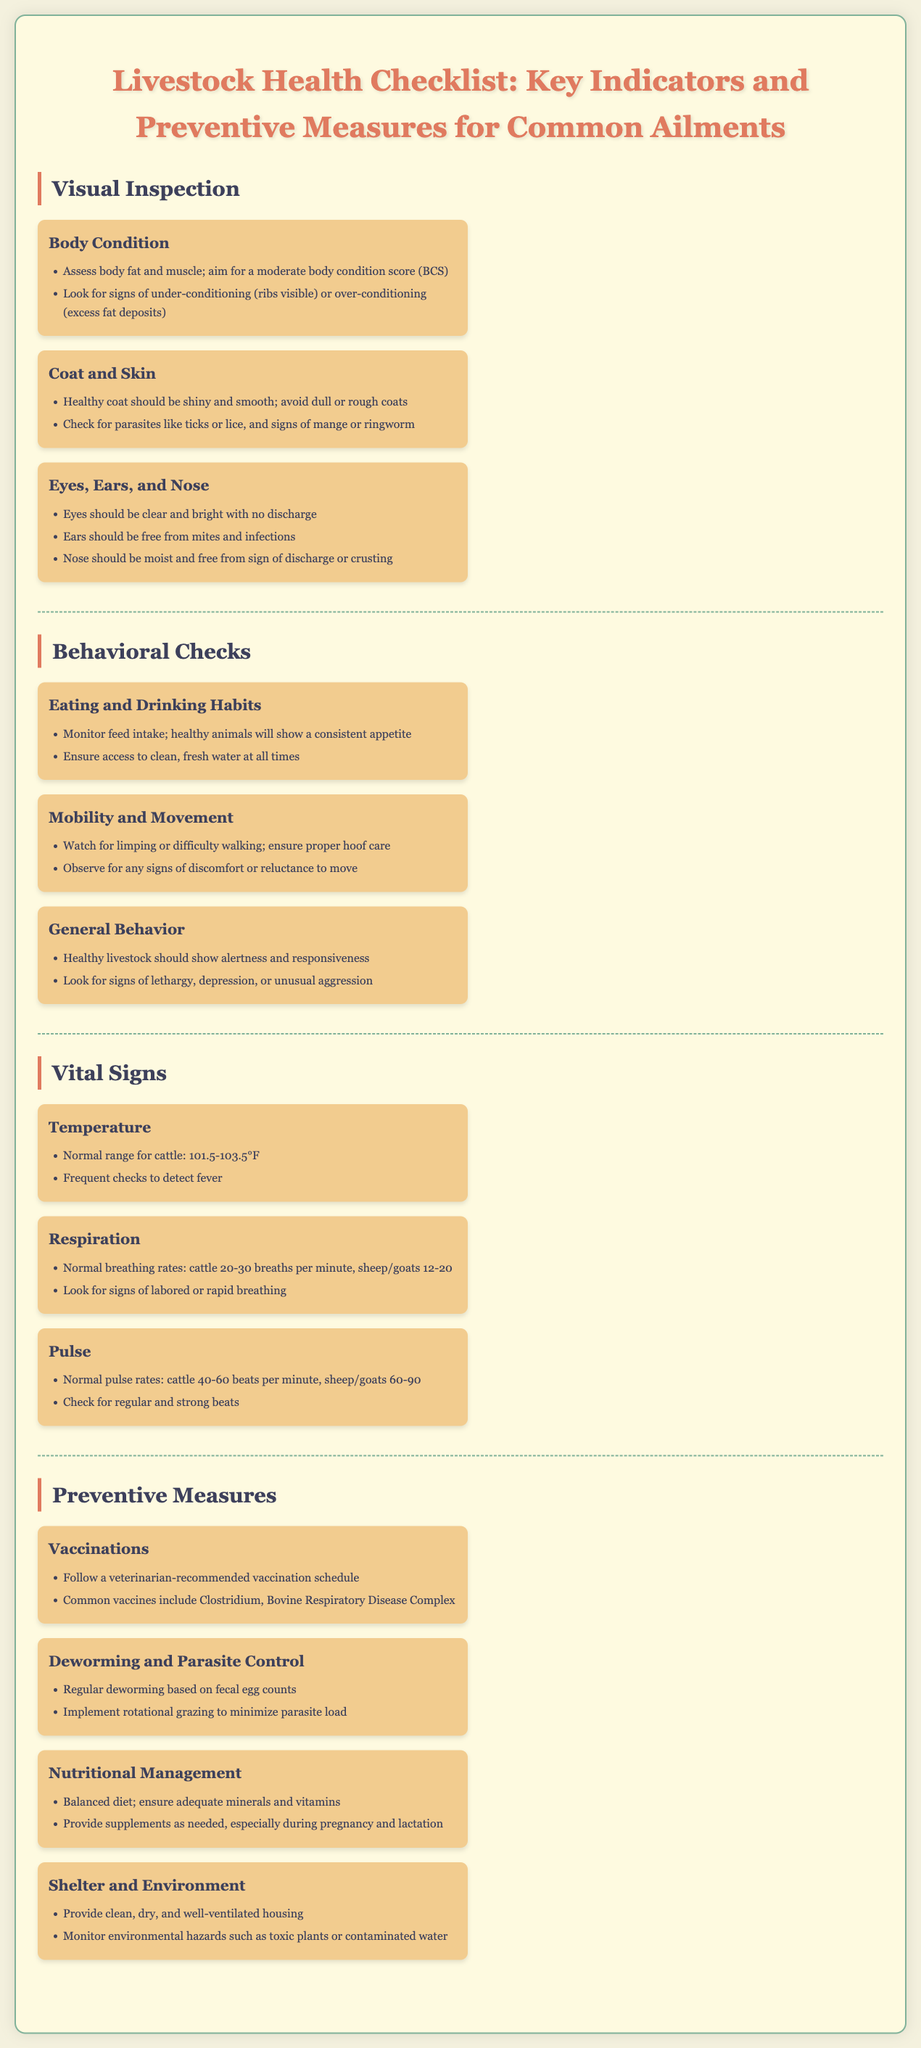What is the normal temperature range for cattle? The normal temperature range for cattle is specified in the document as 101.5-103.5°F.
Answer: 101.5-103.5°F What should a healthy coat look like? The document states that a healthy coat should be shiny and smooth, avoiding a dull or rough appearance.
Answer: Shiny and smooth What are two signs of under-conditioning in livestock? The checklist indicates that visible ribs and excess fat deposits are signs of under-conditioning.
Answer: Ribs visible, excess fat deposits What is the normal respiration rate for cattle? Normal breathing rates for cattle are listed in the document as 20-30 breaths per minute.
Answer: 20-30 breaths per minute Which preventive measure involves a veterinarian? The document highlights vaccinations as a preventive measure that should follow a veterinarian-recommended schedule.
Answer: Vaccinations What is a common vaccine mentioned in the document? The document provides "Clostridium" as a common vaccine.
Answer: Clostridium What should you observe for under general behavior? The document suggests looking for signs of lethargy, depression, or unusual aggression in livestock behavior.
Answer: Lethargy, depression, or unusual aggression Which preventive measure helps with parasite control? The document mentions deworming and implementing rotational grazing as measures for parasite control.
Answer: Deworming and rotational grazing What is a key indicator of body condition? Body fat and muscle assessment is noted as a key indicator of body condition in the document.
Answer: Body fat and muscle assessment 